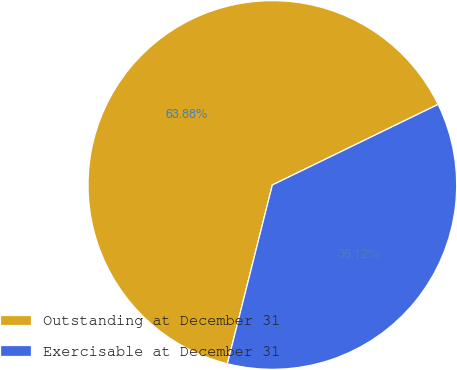Convert chart to OTSL. <chart><loc_0><loc_0><loc_500><loc_500><pie_chart><fcel>Outstanding at December 31<fcel>Exercisable at December 31<nl><fcel>63.88%<fcel>36.12%<nl></chart> 